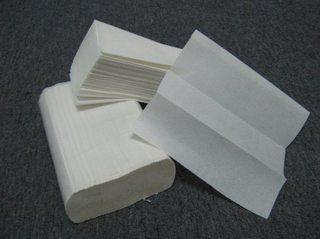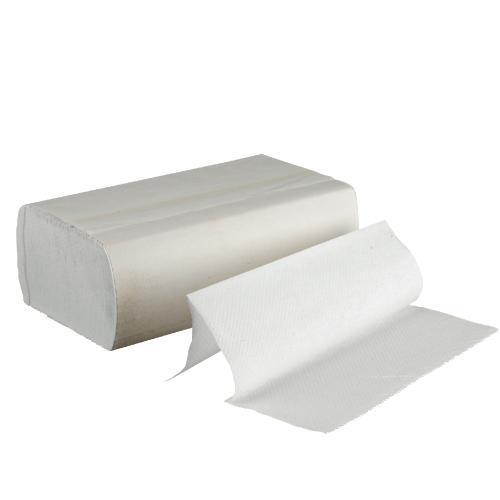The first image is the image on the left, the second image is the image on the right. Examine the images to the left and right. Is the description "A clear paper towel holder is full and has one towel hanging out the bottom." accurate? Answer yes or no. No. The first image is the image on the left, the second image is the image on the right. Examine the images to the left and right. Is the description "In at least one image there is a clear plastic paper towel holder with the white paper towel coming out the bottom." accurate? Answer yes or no. No. 